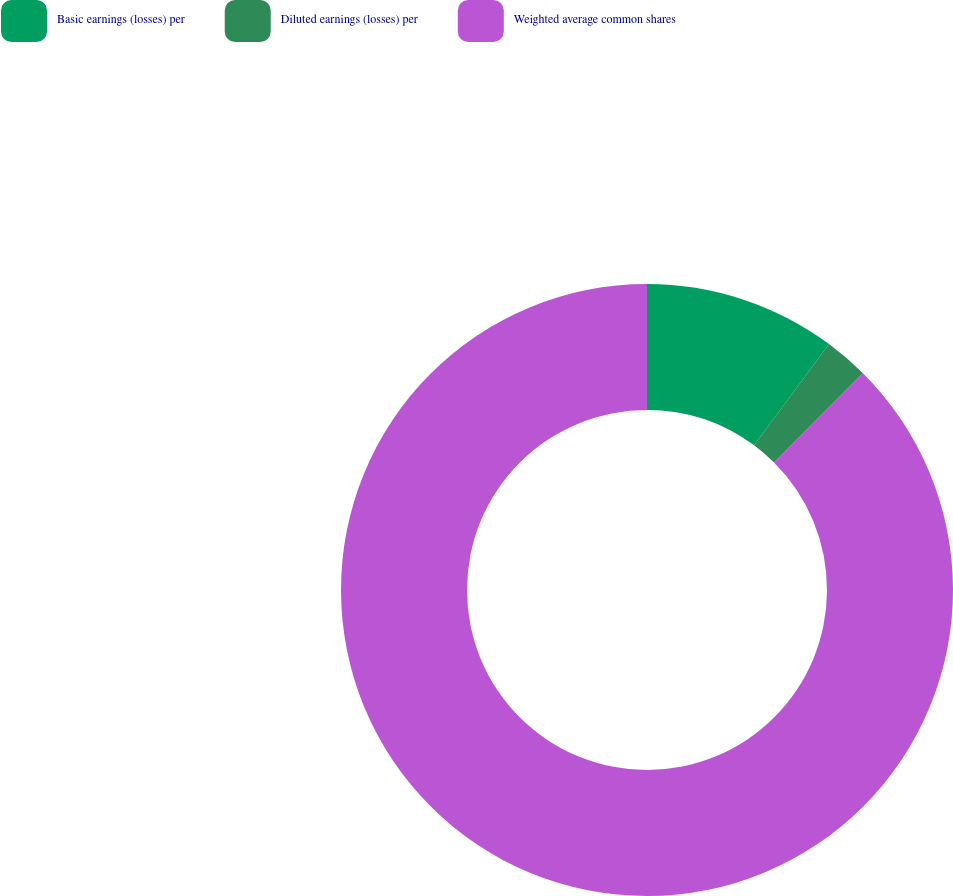<chart> <loc_0><loc_0><loc_500><loc_500><pie_chart><fcel>Basic earnings (losses) per<fcel>Diluted earnings (losses) per<fcel>Weighted average common shares<nl><fcel>10.14%<fcel>2.33%<fcel>87.53%<nl></chart> 